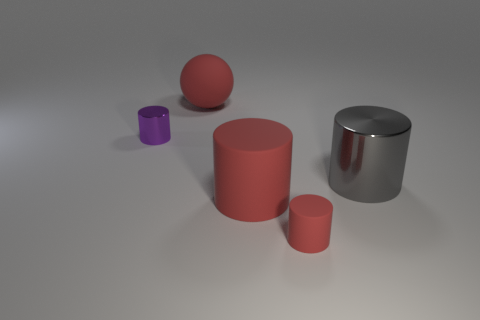What is the shape of the gray shiny object?
Offer a terse response. Cylinder. The tiny cylinder that is the same material as the large gray cylinder is what color?
Your answer should be very brief. Purple. How many purple things are spheres or big objects?
Your response must be concise. 0. Is the number of small purple cylinders greater than the number of small cyan metal cubes?
Your answer should be compact. Yes. What number of objects are large rubber objects that are behind the big red matte cylinder or red rubber things behind the purple object?
Provide a short and direct response. 1. There is a matte ball that is the same size as the gray shiny cylinder; what color is it?
Make the answer very short. Red. Do the purple thing and the sphere have the same material?
Ensure brevity in your answer.  No. What material is the red object behind the tiny thing behind the tiny red object made of?
Provide a succinct answer. Rubber. Is the number of red matte things behind the red rubber ball greater than the number of matte balls?
Your answer should be compact. No. How many other objects are there of the same size as the purple shiny thing?
Ensure brevity in your answer.  1. 